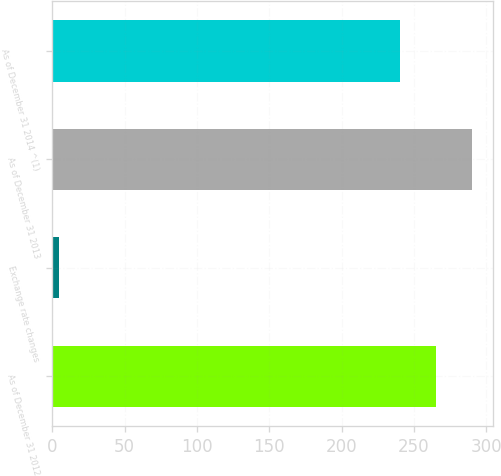Convert chart to OTSL. <chart><loc_0><loc_0><loc_500><loc_500><bar_chart><fcel>As of December 31 2012<fcel>Exchange rate changes<fcel>As of December 31 2013<fcel>As of December 31 2014 ^(1)<nl><fcel>264.9<fcel>5<fcel>289.8<fcel>240<nl></chart> 